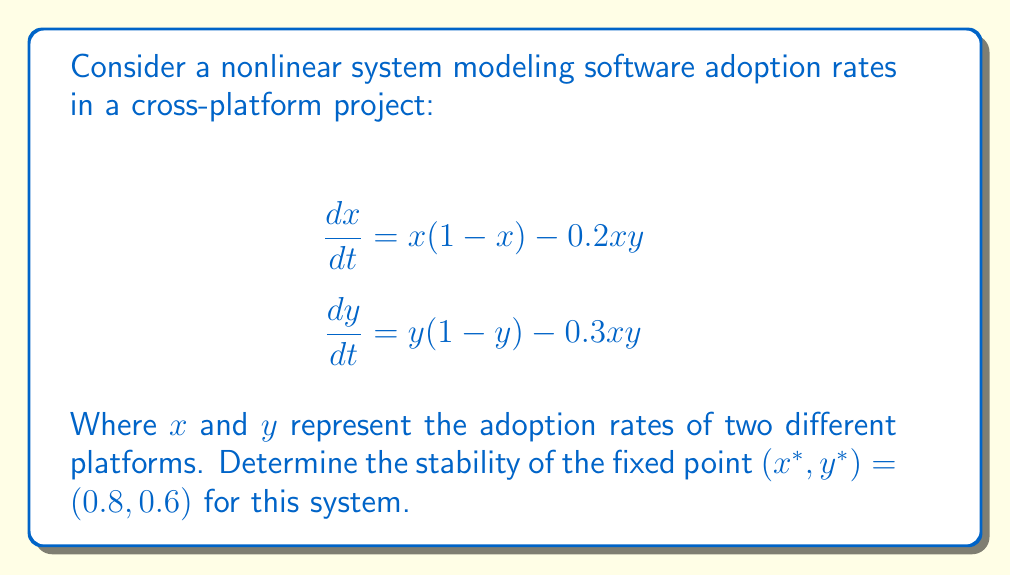Give your solution to this math problem. To analyze the stability of the fixed point, we need to follow these steps:

1) Calculate the Jacobian matrix of the system:
   $$J = \begin{bmatrix}
   \frac{\partial f_1}{\partial x} & \frac{\partial f_1}{\partial y} \\
   \frac{\partial f_2}{\partial x} & \frac{\partial f_2}{\partial y}
   \end{bmatrix}$$

   Where $f_1 = x(1-x) - 0.2xy$ and $f_2 = y(1-y) - 0.3xy$

2) Compute the partial derivatives:
   $$\frac{\partial f_1}{\partial x} = 1 - 2x - 0.2y$$
   $$\frac{\partial f_1}{\partial y} = -0.2x$$
   $$\frac{\partial f_2}{\partial x} = -0.3y$$
   $$\frac{\partial f_2}{\partial y} = 1 - 2y - 0.3x$$

3) Write the Jacobian matrix:
   $$J = \begin{bmatrix}
   1 - 2x - 0.2y & -0.2x \\
   -0.3y & 1 - 2y - 0.3x
   \end{bmatrix}$$

4) Evaluate the Jacobian at the fixed point $(0.8, 0.6)$:
   $$J_{(0.8, 0.6)} = \begin{bmatrix}
   1 - 2(0.8) - 0.2(0.6) & -0.2(0.8) \\
   -0.3(0.6) & 1 - 2(0.6) - 0.3(0.8)
   \end{bmatrix}$$

   $$J_{(0.8, 0.6)} = \begin{bmatrix}
   -0.72 & -0.16 \\
   -0.18 & -0.44
   \end{bmatrix}$$

5) Calculate the eigenvalues of $J_{(0.8, 0.6)}$:
   $$\det(J_{(0.8, 0.6)} - \lambda I) = 0$$
   $$\begin{vmatrix}
   -0.72 - \lambda & -0.16 \\
   -0.18 & -0.44 - \lambda
   \end{vmatrix} = 0$$

   $$(-0.72 - \lambda)(-0.44 - \lambda) - (-0.16)(-0.18) = 0$$
   $$\lambda^2 + 1.16\lambda + 0.2876 = 0$$

6) Solve the quadratic equation:
   $$\lambda = \frac{-1.16 \pm \sqrt{1.16^2 - 4(0.2876)}}{2}$$
   $$\lambda_1 \approx -0.9314$$
   $$\lambda_2 \approx -0.2286$$

7) Analyze the eigenvalues:
   Both eigenvalues are real and negative, indicating that the fixed point is a stable node.
Answer: Stable node 